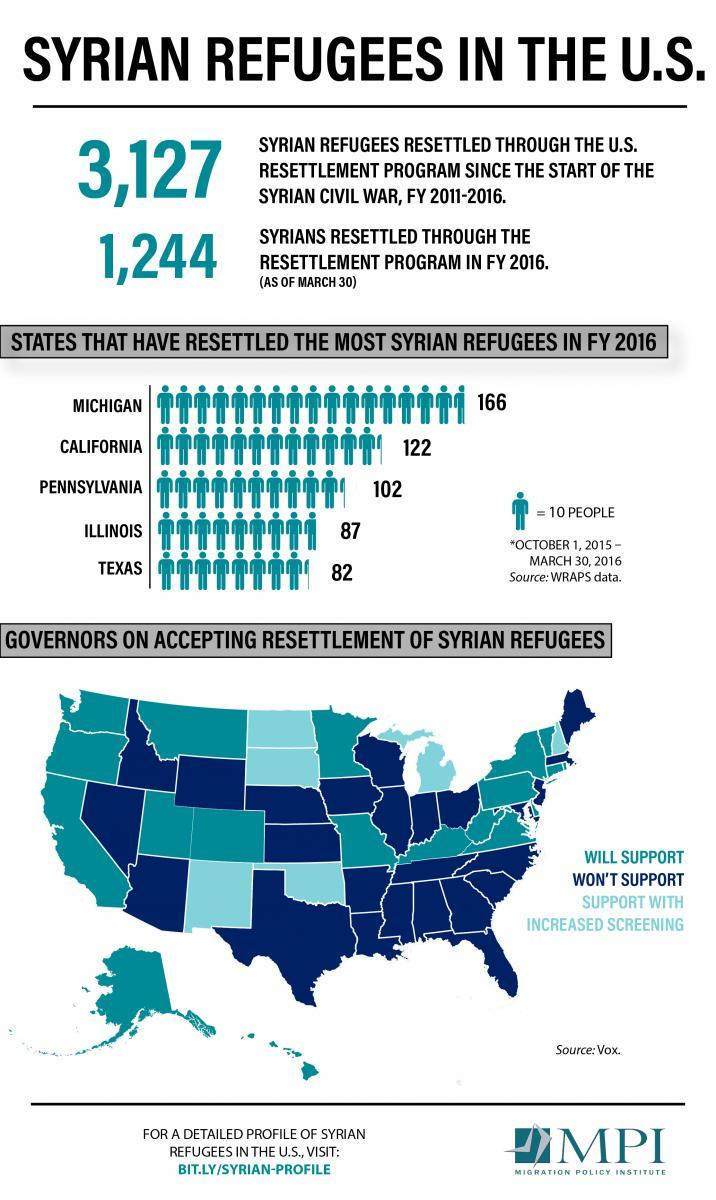How many islands will support the Resettlement of Syrian Refugees?
Answer the question with a short phrase. 2 Which is the state with second least number of Syrian Refugees? Illinois How many states support the Resettlement of Syrian Refugees with increased screening? 7 How many states won't support the Resettlement of Syrian Refugees? 25 Which is the state with second highest number of Syrian Refugees? California 